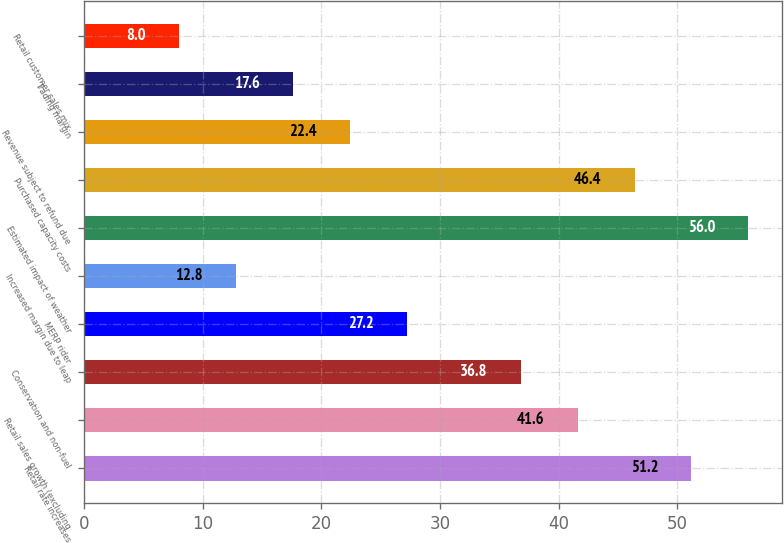<chart> <loc_0><loc_0><loc_500><loc_500><bar_chart><fcel>Retail rate increases<fcel>Retail sales growth (excluding<fcel>Conservation and non-fuel<fcel>MERP rider<fcel>Increased margin due to leap<fcel>Estimated impact of weather<fcel>Purchased capacity costs<fcel>Revenue subject to refund due<fcel>Trading margin<fcel>Retail customer sales mix<nl><fcel>51.2<fcel>41.6<fcel>36.8<fcel>27.2<fcel>12.8<fcel>56<fcel>46.4<fcel>22.4<fcel>17.6<fcel>8<nl></chart> 